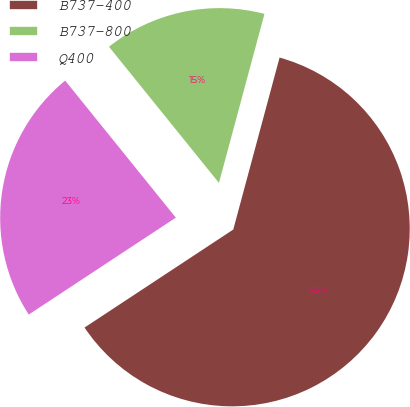<chart> <loc_0><loc_0><loc_500><loc_500><pie_chart><fcel>B737-400<fcel>B737-800<fcel>Q400<nl><fcel>61.54%<fcel>15.0%<fcel>23.46%<nl></chart> 